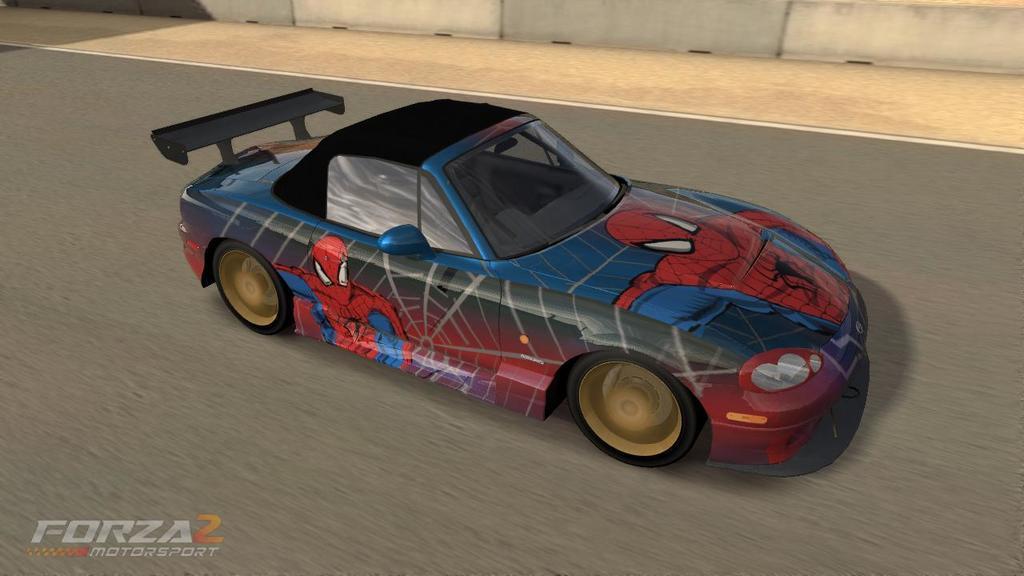In one or two sentences, can you explain what this image depicts? This is an animated image, in this picture we can see car on the road. In the background of the image we can see wall. In the bottom left side of the image we can see text. 